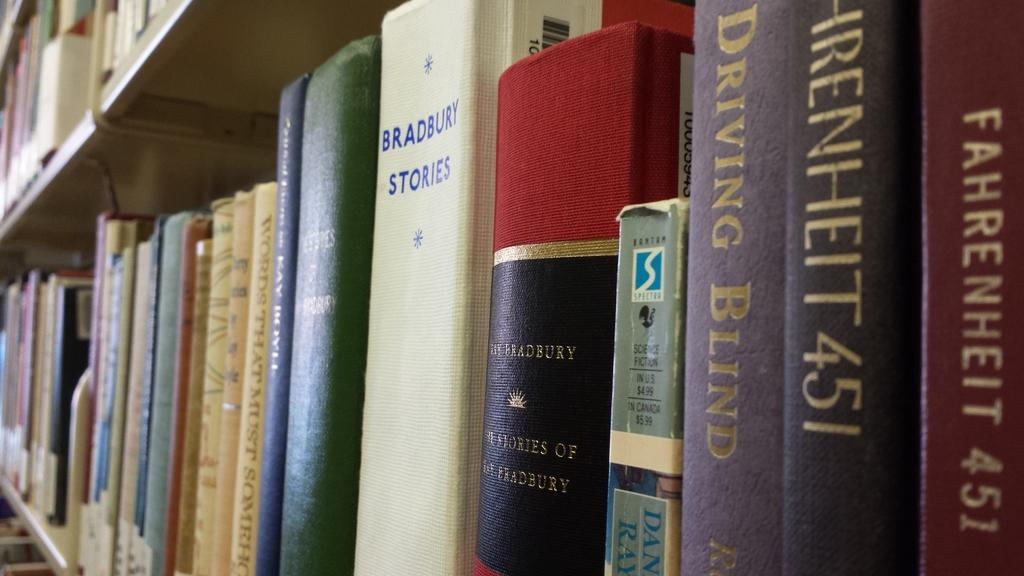<image>
Summarize the visual content of the image. the word driving is on a purple book 